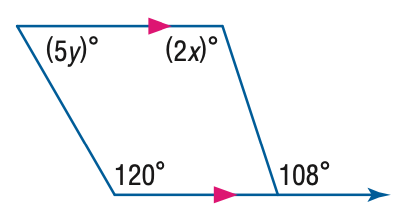Answer the mathemtical geometry problem and directly provide the correct option letter.
Question: Find the value of the variable y in the figure.
Choices: A: 12 B: 24 C: 60 D: 120 A 